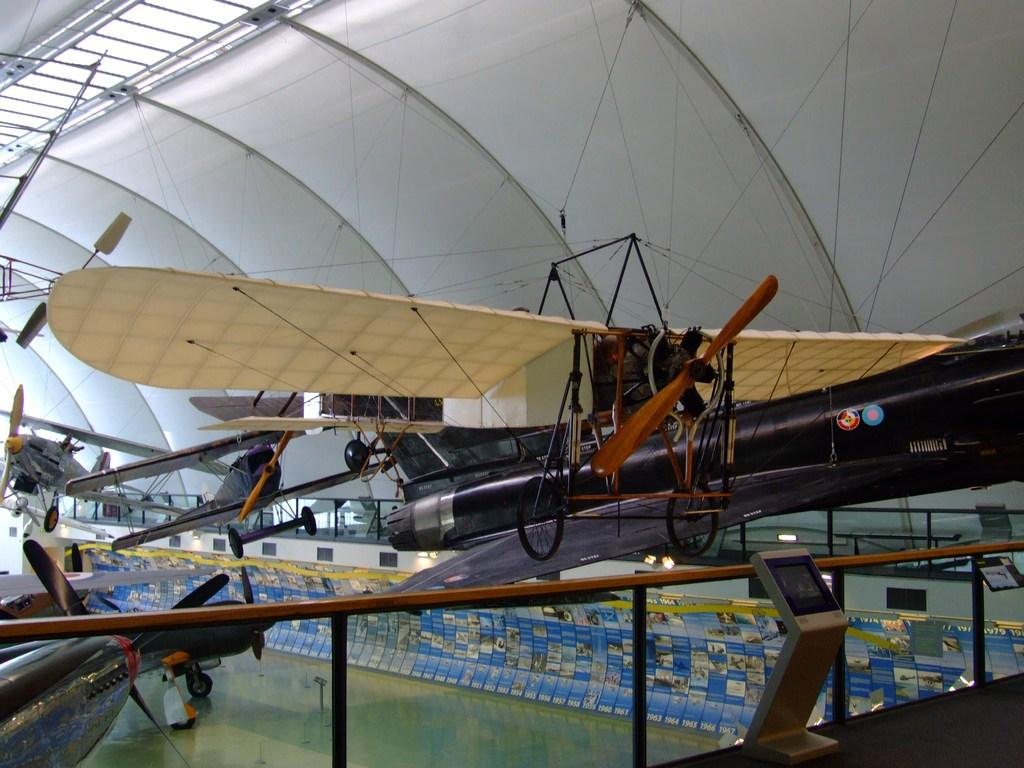What type of surface can be seen in the image? There is ground visible in the image. What are the main subjects in the image? There are aircrafts in the image. Are there any illumination sources in the image? Yes, there are lights in the image. What else can be seen in the image besides the aircrafts and lights? There are objects in the image. What is visible in the background of the image? There is a roof visible in the background of the image. Can you see a cow grazing on the ground in the image? There is no cow present in the image; it features aircrafts and lights. What type of throne is depicted in the image? There is no throne present in the image; it features aircrafts, lights, and objects. 